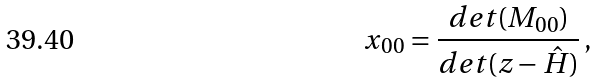<formula> <loc_0><loc_0><loc_500><loc_500>x _ { 0 0 } = \frac { d e t ( M _ { 0 0 } ) } { d e t ( z - \hat { H } ) } \, ,</formula> 